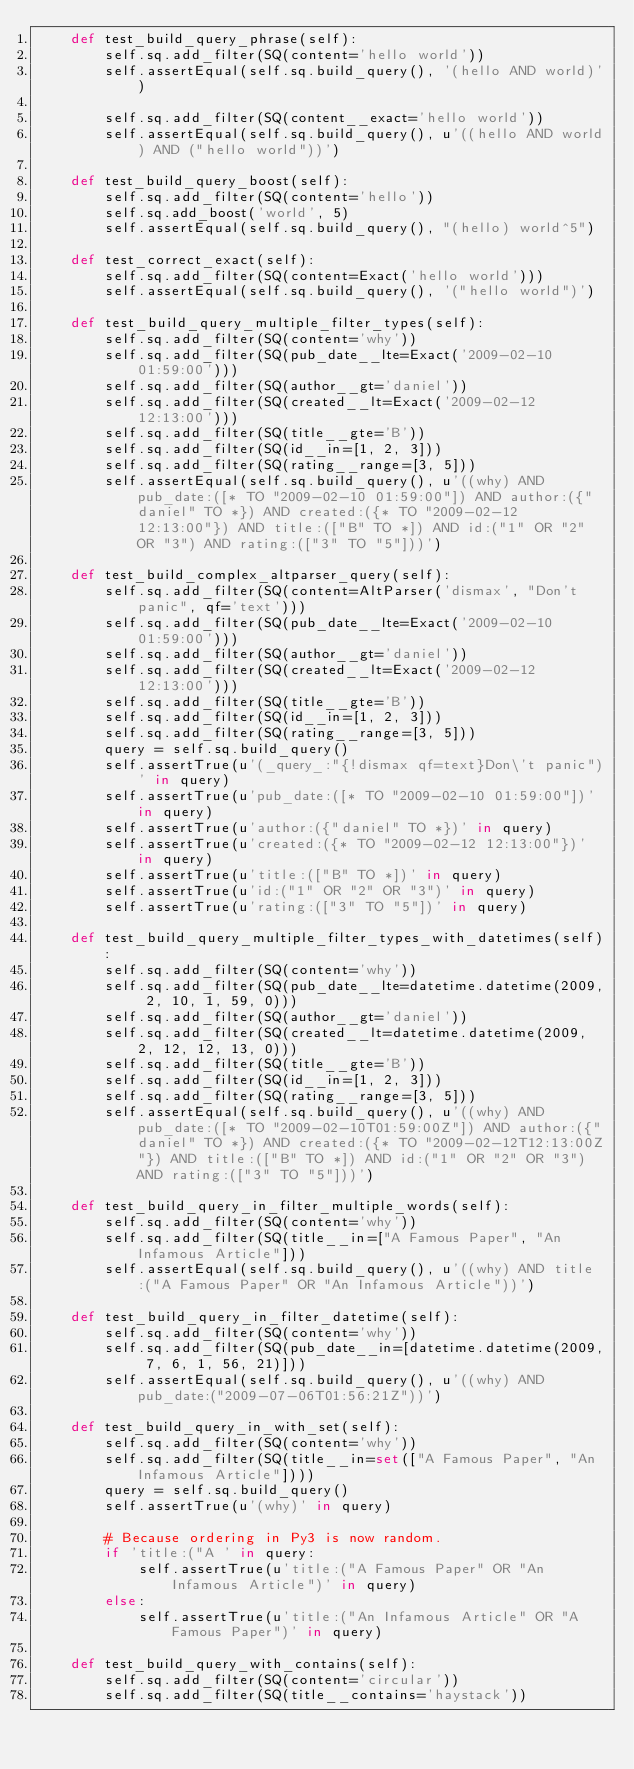Convert code to text. <code><loc_0><loc_0><loc_500><loc_500><_Python_>    def test_build_query_phrase(self):
        self.sq.add_filter(SQ(content='hello world'))
        self.assertEqual(self.sq.build_query(), '(hello AND world)')

        self.sq.add_filter(SQ(content__exact='hello world'))
        self.assertEqual(self.sq.build_query(), u'((hello AND world) AND ("hello world"))')

    def test_build_query_boost(self):
        self.sq.add_filter(SQ(content='hello'))
        self.sq.add_boost('world', 5)
        self.assertEqual(self.sq.build_query(), "(hello) world^5")

    def test_correct_exact(self):
        self.sq.add_filter(SQ(content=Exact('hello world')))
        self.assertEqual(self.sq.build_query(), '("hello world")')

    def test_build_query_multiple_filter_types(self):
        self.sq.add_filter(SQ(content='why'))
        self.sq.add_filter(SQ(pub_date__lte=Exact('2009-02-10 01:59:00')))
        self.sq.add_filter(SQ(author__gt='daniel'))
        self.sq.add_filter(SQ(created__lt=Exact('2009-02-12 12:13:00')))
        self.sq.add_filter(SQ(title__gte='B'))
        self.sq.add_filter(SQ(id__in=[1, 2, 3]))
        self.sq.add_filter(SQ(rating__range=[3, 5]))
        self.assertEqual(self.sq.build_query(), u'((why) AND pub_date:([* TO "2009-02-10 01:59:00"]) AND author:({"daniel" TO *}) AND created:({* TO "2009-02-12 12:13:00"}) AND title:(["B" TO *]) AND id:("1" OR "2" OR "3") AND rating:(["3" TO "5"]))')

    def test_build_complex_altparser_query(self):
        self.sq.add_filter(SQ(content=AltParser('dismax', "Don't panic", qf='text')))
        self.sq.add_filter(SQ(pub_date__lte=Exact('2009-02-10 01:59:00')))
        self.sq.add_filter(SQ(author__gt='daniel'))
        self.sq.add_filter(SQ(created__lt=Exact('2009-02-12 12:13:00')))
        self.sq.add_filter(SQ(title__gte='B'))
        self.sq.add_filter(SQ(id__in=[1, 2, 3]))
        self.sq.add_filter(SQ(rating__range=[3, 5]))
        query = self.sq.build_query()
        self.assertTrue(u'(_query_:"{!dismax qf=text}Don\'t panic")' in query)
        self.assertTrue(u'pub_date:([* TO "2009-02-10 01:59:00"])' in query)
        self.assertTrue(u'author:({"daniel" TO *})' in query)
        self.assertTrue(u'created:({* TO "2009-02-12 12:13:00"})' in query)
        self.assertTrue(u'title:(["B" TO *])' in query)
        self.assertTrue(u'id:("1" OR "2" OR "3")' in query)
        self.assertTrue(u'rating:(["3" TO "5"])' in query)

    def test_build_query_multiple_filter_types_with_datetimes(self):
        self.sq.add_filter(SQ(content='why'))
        self.sq.add_filter(SQ(pub_date__lte=datetime.datetime(2009, 2, 10, 1, 59, 0)))
        self.sq.add_filter(SQ(author__gt='daniel'))
        self.sq.add_filter(SQ(created__lt=datetime.datetime(2009, 2, 12, 12, 13, 0)))
        self.sq.add_filter(SQ(title__gte='B'))
        self.sq.add_filter(SQ(id__in=[1, 2, 3]))
        self.sq.add_filter(SQ(rating__range=[3, 5]))
        self.assertEqual(self.sq.build_query(), u'((why) AND pub_date:([* TO "2009-02-10T01:59:00Z"]) AND author:({"daniel" TO *}) AND created:({* TO "2009-02-12T12:13:00Z"}) AND title:(["B" TO *]) AND id:("1" OR "2" OR "3") AND rating:(["3" TO "5"]))')

    def test_build_query_in_filter_multiple_words(self):
        self.sq.add_filter(SQ(content='why'))
        self.sq.add_filter(SQ(title__in=["A Famous Paper", "An Infamous Article"]))
        self.assertEqual(self.sq.build_query(), u'((why) AND title:("A Famous Paper" OR "An Infamous Article"))')

    def test_build_query_in_filter_datetime(self):
        self.sq.add_filter(SQ(content='why'))
        self.sq.add_filter(SQ(pub_date__in=[datetime.datetime(2009, 7, 6, 1, 56, 21)]))
        self.assertEqual(self.sq.build_query(), u'((why) AND pub_date:("2009-07-06T01:56:21Z"))')

    def test_build_query_in_with_set(self):
        self.sq.add_filter(SQ(content='why'))
        self.sq.add_filter(SQ(title__in=set(["A Famous Paper", "An Infamous Article"])))
        query = self.sq.build_query()
        self.assertTrue(u'(why)' in query)

        # Because ordering in Py3 is now random.
        if 'title:("A ' in query:
            self.assertTrue(u'title:("A Famous Paper" OR "An Infamous Article")' in query)
        else:
            self.assertTrue(u'title:("An Infamous Article" OR "A Famous Paper")' in query)

    def test_build_query_with_contains(self):
        self.sq.add_filter(SQ(content='circular'))
        self.sq.add_filter(SQ(title__contains='haystack'))</code> 